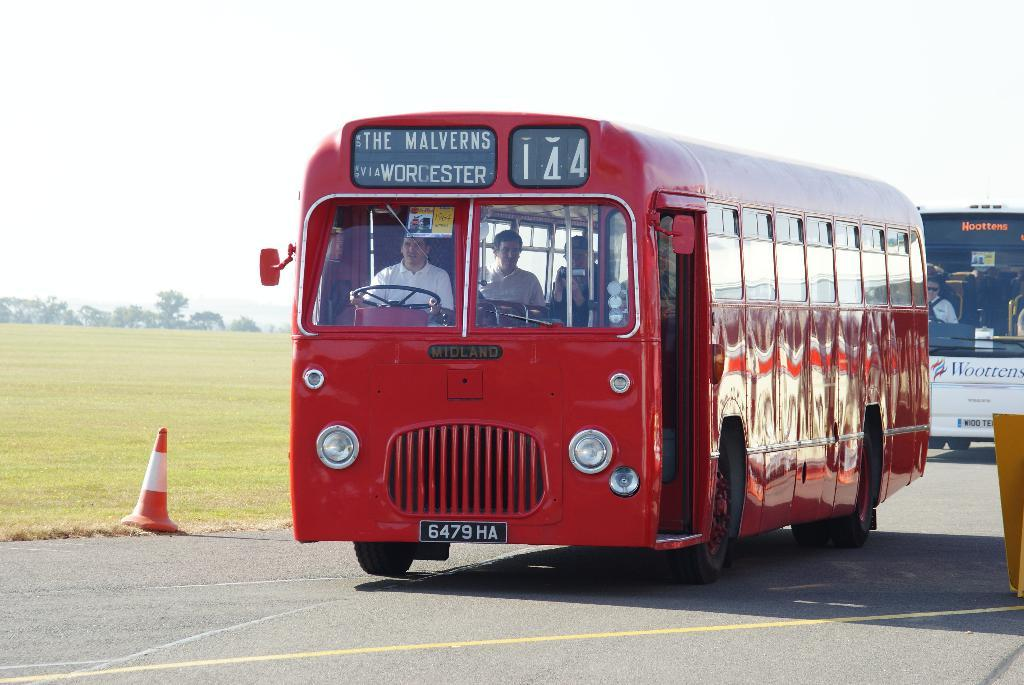<image>
Summarize the visual content of the image. a red bus number 14 for the Malverns 